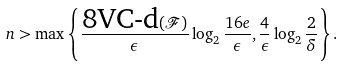Convert formula to latex. <formula><loc_0><loc_0><loc_500><loc_500>n > \max \left \{ \frac { \text {8VC-d} ( \mathcal { F } ) } { \epsilon } \log _ { 2 } \frac { 1 6 e } { \epsilon } , \frac { 4 } { \epsilon } \log _ { 2 } \frac { 2 } { \delta } \right \} .</formula> 